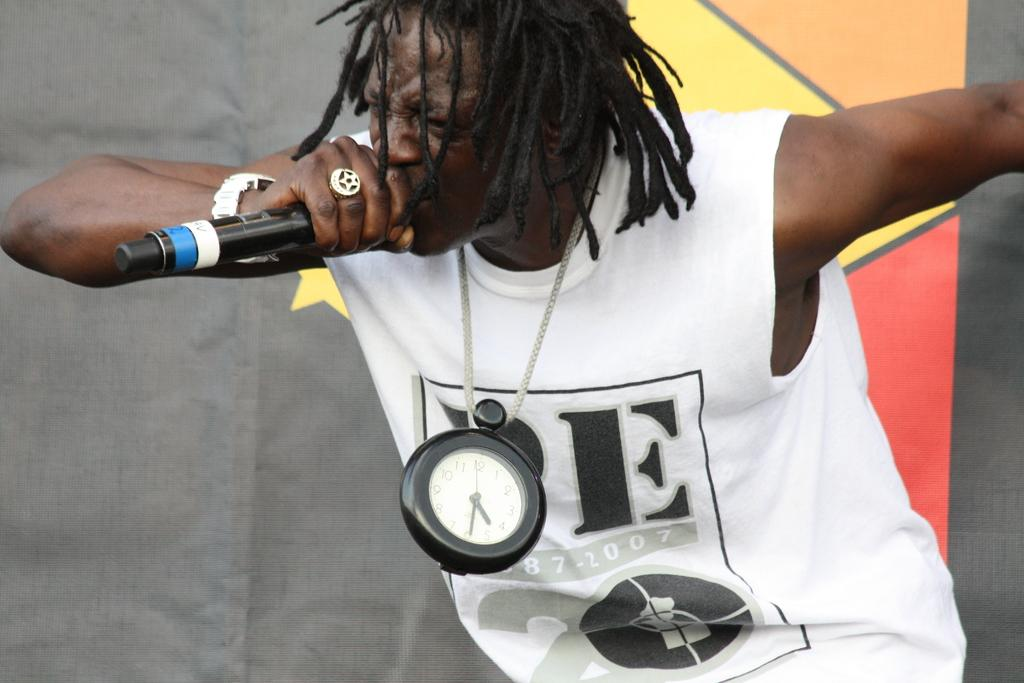Provide a one-sentence caption for the provided image. A singer holding a mic and wearing a white t-shirt on which the letter E is visible and the year 2007. 